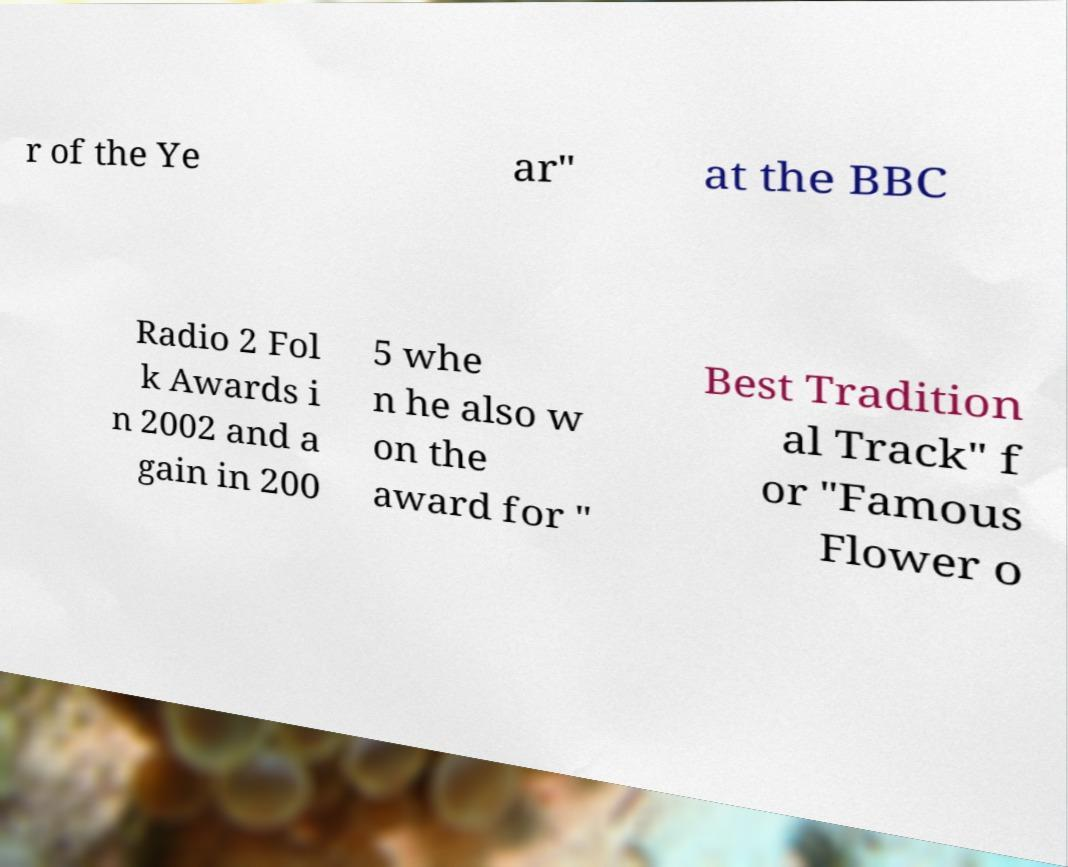For documentation purposes, I need the text within this image transcribed. Could you provide that? r of the Ye ar" at the BBC Radio 2 Fol k Awards i n 2002 and a gain in 200 5 whe n he also w on the award for " Best Tradition al Track" f or "Famous Flower o 